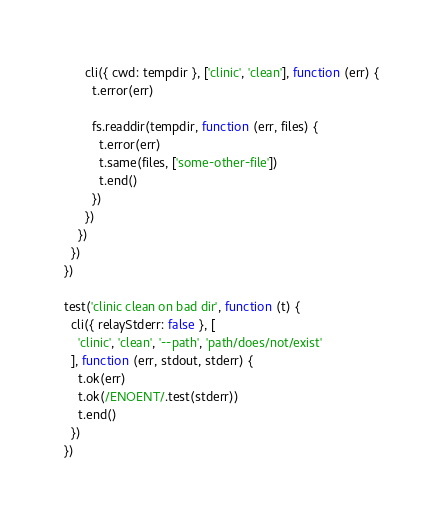<code> <loc_0><loc_0><loc_500><loc_500><_JavaScript_>      cli({ cwd: tempdir }, ['clinic', 'clean'], function (err) {
        t.error(err)

        fs.readdir(tempdir, function (err, files) {
          t.error(err)
          t.same(files, ['some-other-file'])
          t.end()
        })
      })
    })
  })
})

test('clinic clean on bad dir', function (t) {
  cli({ relayStderr: false }, [
    'clinic', 'clean', '--path', 'path/does/not/exist'
  ], function (err, stdout, stderr) {
    t.ok(err)
    t.ok(/ENOENT/.test(stderr))
    t.end()
  })
})
</code> 